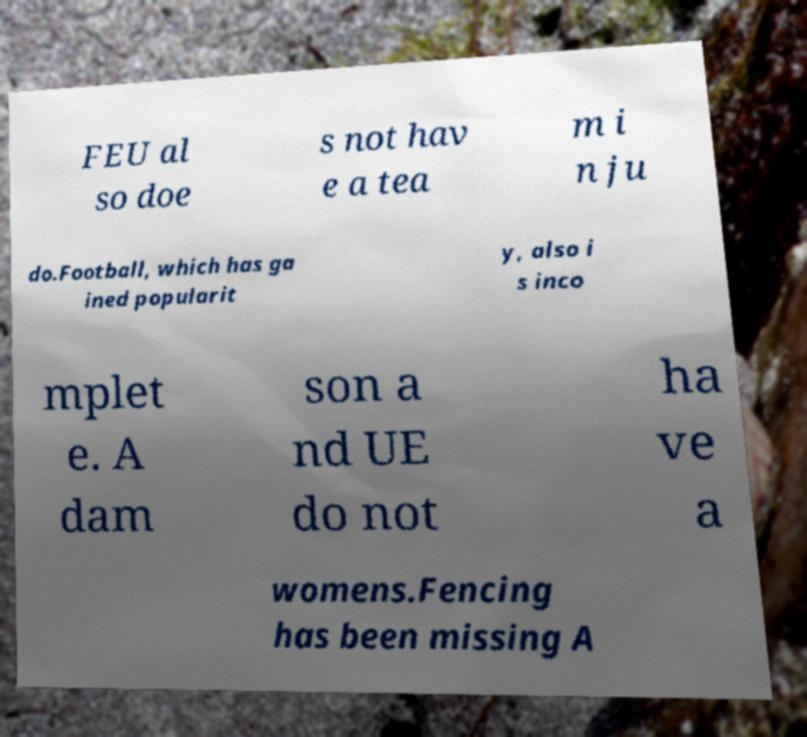For documentation purposes, I need the text within this image transcribed. Could you provide that? FEU al so doe s not hav e a tea m i n ju do.Football, which has ga ined popularit y, also i s inco mplet e. A dam son a nd UE do not ha ve a womens.Fencing has been missing A 